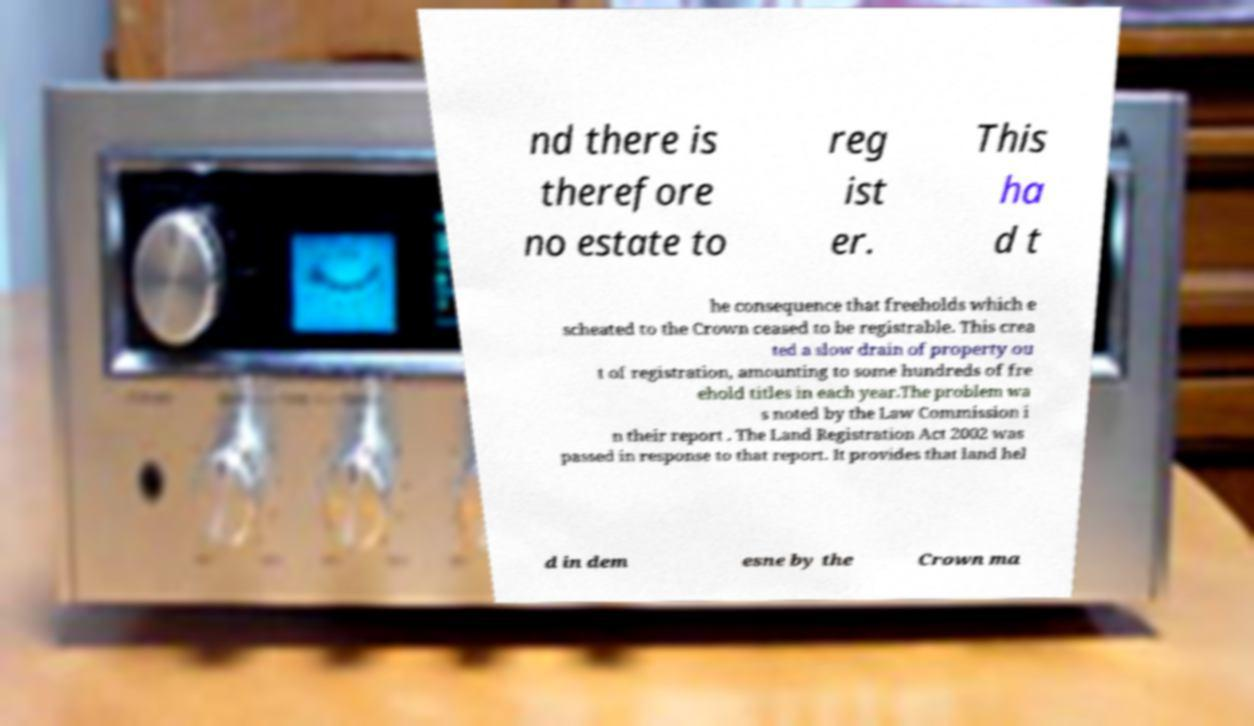I need the written content from this picture converted into text. Can you do that? nd there is therefore no estate to reg ist er. This ha d t he consequence that freeholds which e scheated to the Crown ceased to be registrable. This crea ted a slow drain of property ou t of registration, amounting to some hundreds of fre ehold titles in each year.The problem wa s noted by the Law Commission i n their report . The Land Registration Act 2002 was passed in response to that report. It provides that land hel d in dem esne by the Crown ma 